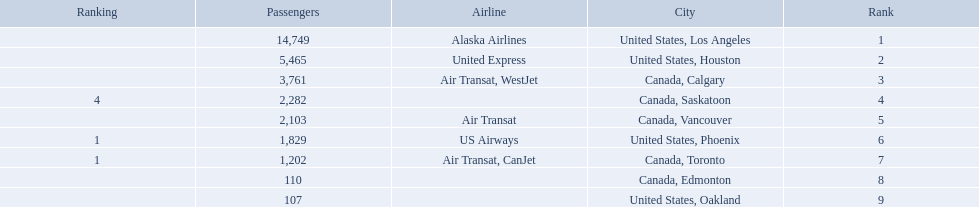What cities do the planes fly to? United States, Los Angeles, United States, Houston, Canada, Calgary, Canada, Saskatoon, Canada, Vancouver, United States, Phoenix, Canada, Toronto, Canada, Edmonton, United States, Oakland. How many people are flying to phoenix, arizona? 1,829. 